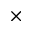Convert formula to latex. <formula><loc_0><loc_0><loc_500><loc_500>\times</formula> 